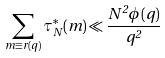<formula> <loc_0><loc_0><loc_500><loc_500>\sum _ { m \equiv r ( q ) } \tau _ { N } ^ { * } ( m ) \ll \frac { N ^ { 2 } \phi ( q ) } { q ^ { 2 } }</formula> 